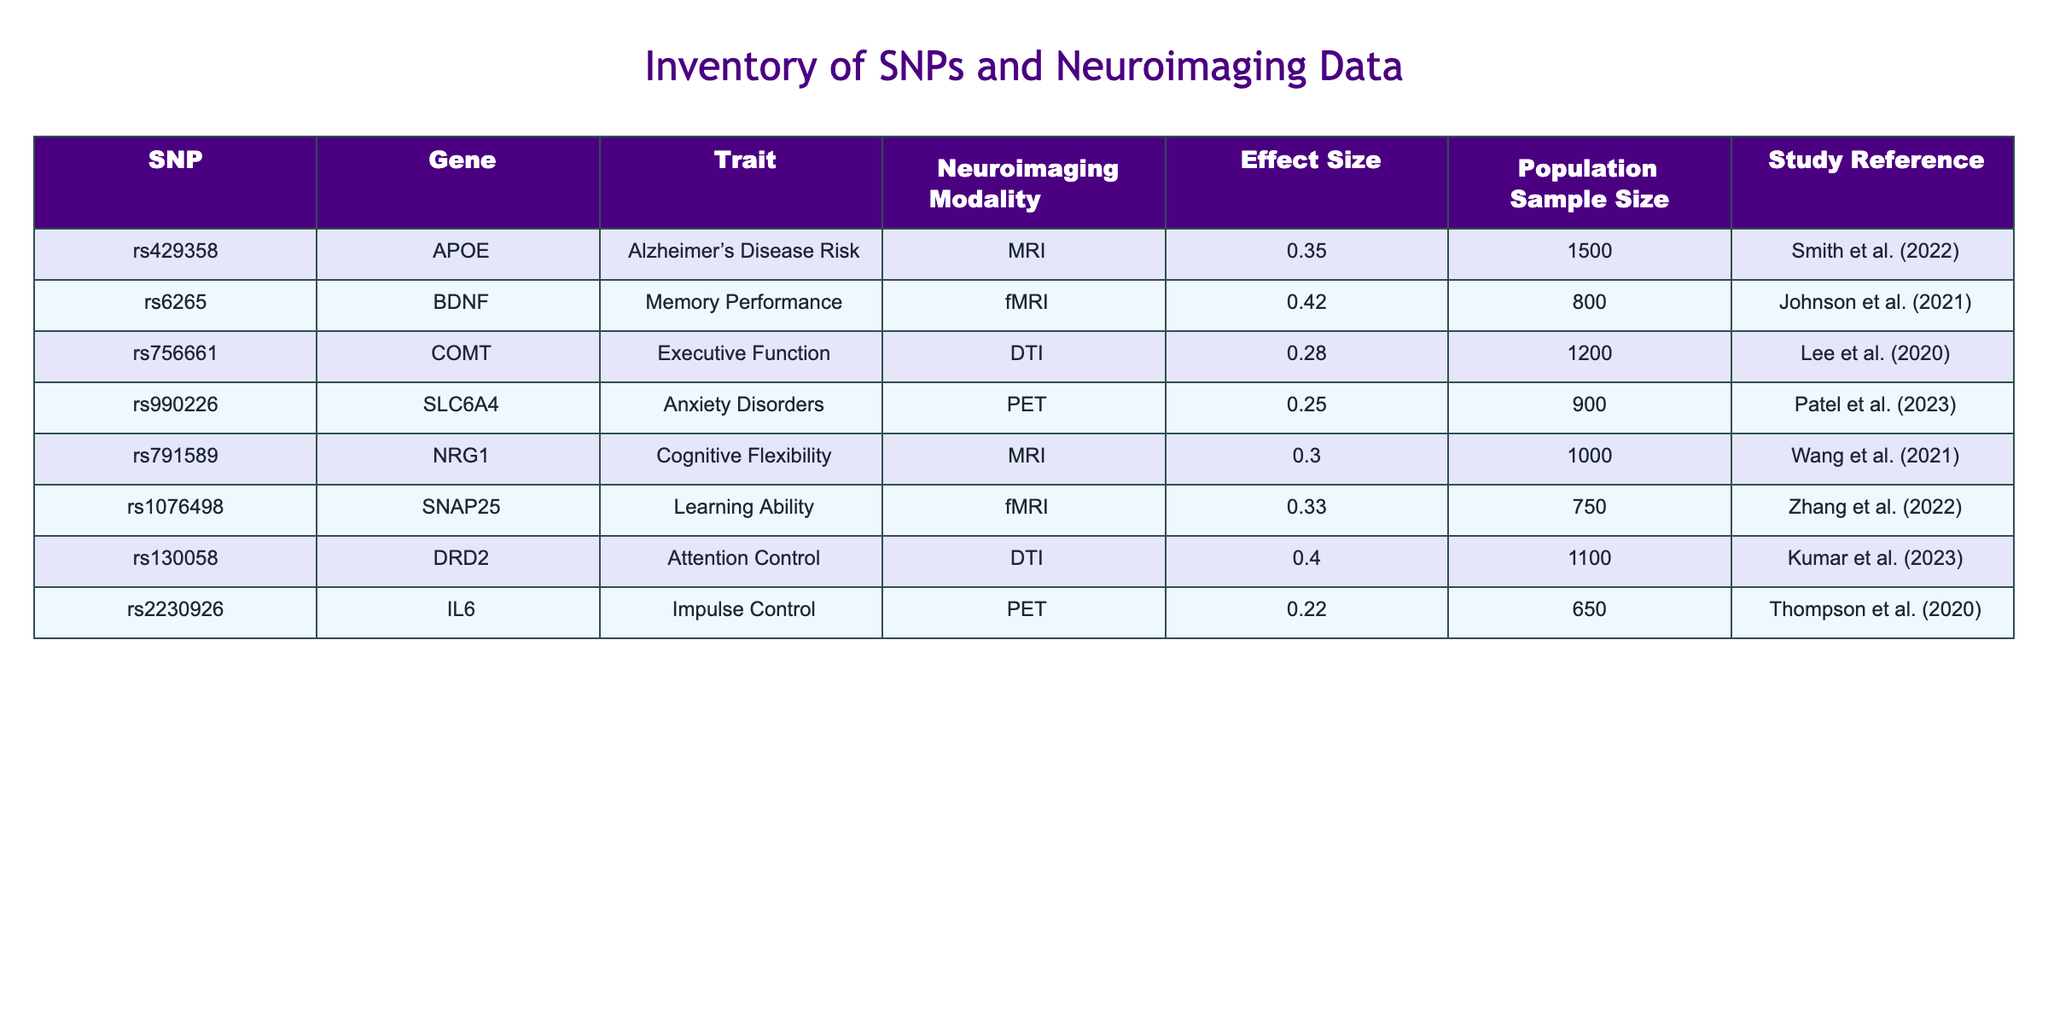What is the effect size associated with the SNP rs6265? The table shows the effect sizes for each SNP. For rs6265, the effect size listed is 0.42.
Answer: 0.42 Which SNP is associated with Alzheimer's Disease Risk? In the table, the SNP associated with Alzheimer's Disease Risk is rs429358.
Answer: rs429358 How many studies have an effect size greater than 0.30? To find this, we can count the number of rows with an effect size greater than 0.30: rs6265 (0.42), rs791589 (0.30), rs1076498 (0.33), and rs130058 (0.40). That totals 4 studies.
Answer: 4 Is there a SNP linked to both memory performance and executive function? After reviewing the table, there are no SNPs that are linked to both memory performance (rs6265) and executive function (rs756661).
Answer: No What is the average effect size of SNPs associated with PET neuroimaging modality? The SNPs linked with PET modality are rs990226 (0.25) and rs2230926 (0.22). The average effect size is calculated by summing these values (0.25 + 0.22 = 0.47) and dividing by the number of SNPs (2). Therefore, the average is 0.47/2 = 0.235.
Answer: 0.235 Which gene related to cognitive flexibility has the highest effect size among the SNPs? Looking at the table, the relevant SNP with cognitive flexibility is rs791589 associated with the NRG1 gene, with an effect size of 0.30. To find if there is a higher effect size, we can compare it to citations about cognitive flexibility. The SNPs in the table do not indicate higher associations.
Answer: NRG1 What trait is associated with the SNP rs2230926? The table provides the information that SNP rs2230926 is linked with impulse control.
Answer: Impulse Control What is the total population sample size across all studies listed in the table? The population sample sizes for each SNP are: 1500, 800, 1200, 900, 1000, 750, 1100, and 650. Summing these gives 1500 + 800 + 1200 + 900 + 1000 + 750 + 1100 + 650 = 5900.
Answer: 5900 Which SNP has the lowest effect size and what trait does it relate to? The lowest effect size in the table is for SNP rs2230926, associated with impulse control, having an effect size of 0.22.
Answer: rs2230926, Impulse Control 